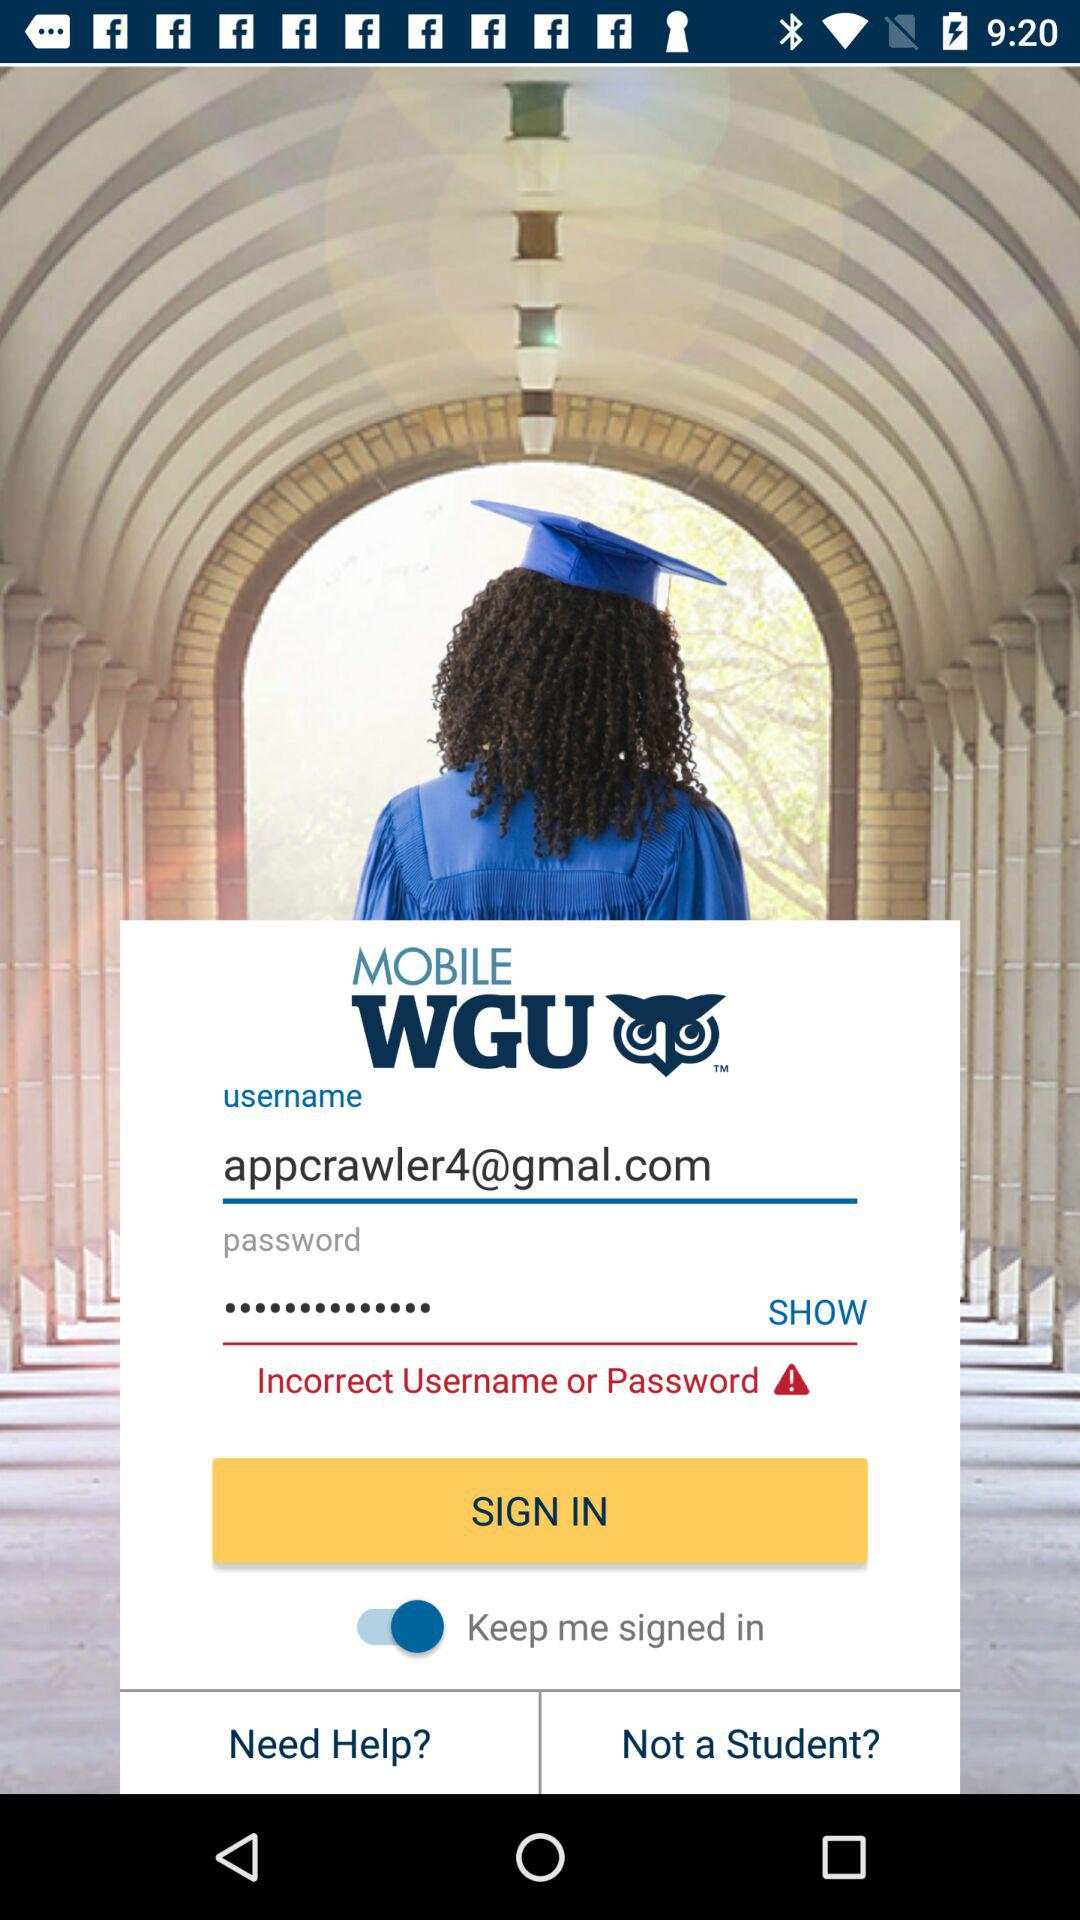What is the email address? The email address is appcrawler4@gmal.com. 